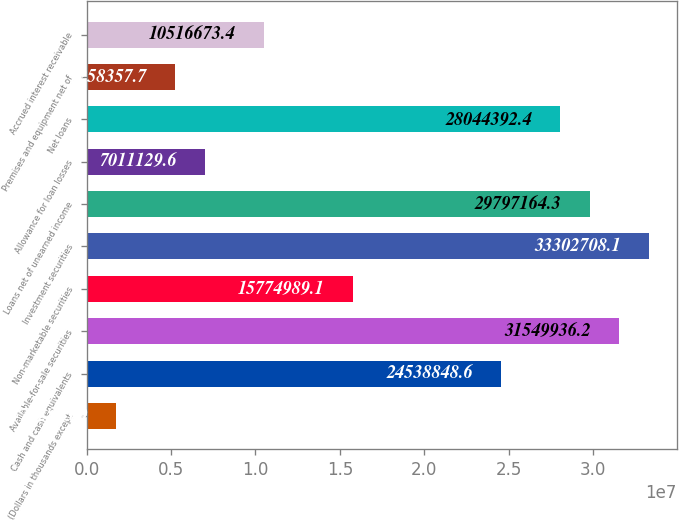Convert chart. <chart><loc_0><loc_0><loc_500><loc_500><bar_chart><fcel>(Dollars in thousands except<fcel>Cash and cash equivalents<fcel>Available-for-sale securities<fcel>Non-marketable securities<fcel>Investment securities<fcel>Loans net of unearned income<fcel>Allowance for loan losses<fcel>Net loans<fcel>Premises and equipment net of<fcel>Accrued interest receivable<nl><fcel>1.75281e+06<fcel>2.45388e+07<fcel>3.15499e+07<fcel>1.5775e+07<fcel>3.33027e+07<fcel>2.97972e+07<fcel>7.01113e+06<fcel>2.80444e+07<fcel>5.25836e+06<fcel>1.05167e+07<nl></chart> 